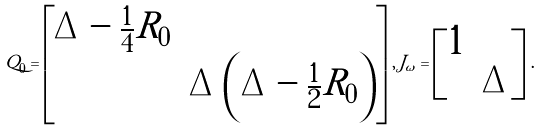<formula> <loc_0><loc_0><loc_500><loc_500>Q _ { 0 } = \begin{bmatrix} \Delta - \frac { 1 } { 4 } R _ { 0 } & \\ & \Delta \left ( \Delta - \frac { 1 } { 2 } R _ { 0 } \right ) \\ \end{bmatrix} \, , \, J _ { \omega } = \begin{bmatrix} 1 & \\ & \Delta \\ \end{bmatrix} \, .</formula> 